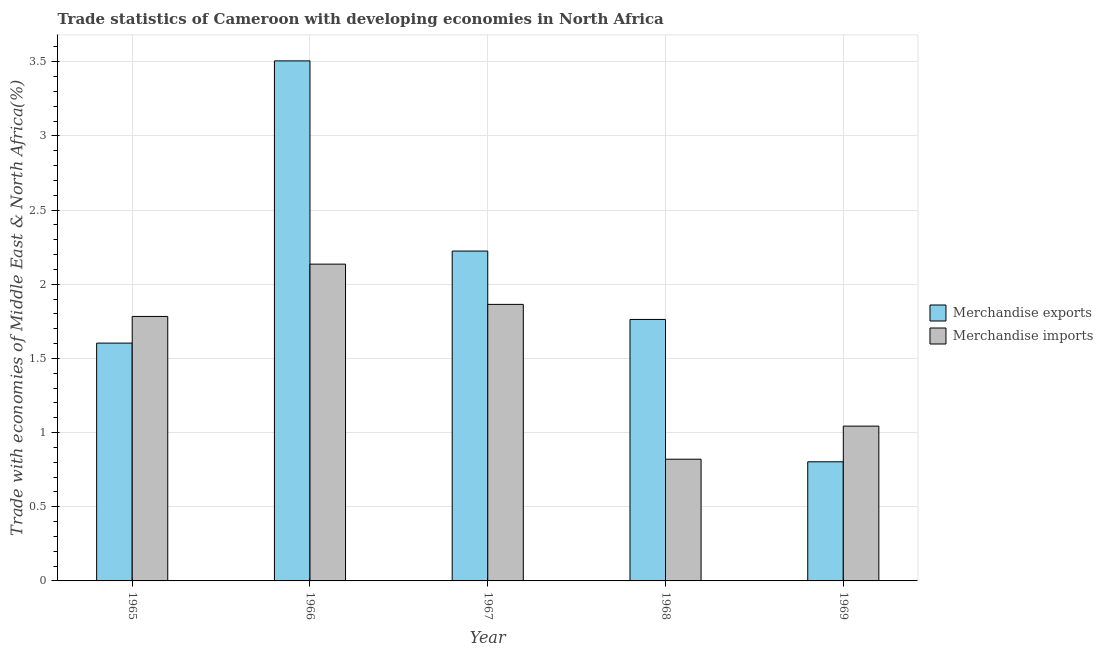Are the number of bars per tick equal to the number of legend labels?
Offer a terse response. Yes. How many bars are there on the 2nd tick from the left?
Offer a very short reply. 2. How many bars are there on the 4th tick from the right?
Your response must be concise. 2. What is the label of the 3rd group of bars from the left?
Ensure brevity in your answer.  1967. What is the merchandise exports in 1966?
Offer a terse response. 3.51. Across all years, what is the maximum merchandise imports?
Offer a terse response. 2.14. Across all years, what is the minimum merchandise imports?
Give a very brief answer. 0.82. In which year was the merchandise exports maximum?
Offer a very short reply. 1966. In which year was the merchandise imports minimum?
Ensure brevity in your answer.  1968. What is the total merchandise imports in the graph?
Offer a very short reply. 7.65. What is the difference between the merchandise imports in 1968 and that in 1969?
Offer a terse response. -0.22. What is the difference between the merchandise exports in 1968 and the merchandise imports in 1967?
Give a very brief answer. -0.46. What is the average merchandise exports per year?
Ensure brevity in your answer.  1.98. In how many years, is the merchandise exports greater than 2.4 %?
Your response must be concise. 1. What is the ratio of the merchandise imports in 1966 to that in 1968?
Your answer should be very brief. 2.6. Is the merchandise imports in 1968 less than that in 1969?
Offer a terse response. Yes. Is the difference between the merchandise imports in 1965 and 1968 greater than the difference between the merchandise exports in 1965 and 1968?
Your answer should be compact. No. What is the difference between the highest and the second highest merchandise exports?
Offer a very short reply. 1.28. What is the difference between the highest and the lowest merchandise exports?
Your response must be concise. 2.7. In how many years, is the merchandise exports greater than the average merchandise exports taken over all years?
Your response must be concise. 2. Is the sum of the merchandise exports in 1965 and 1966 greater than the maximum merchandise imports across all years?
Your answer should be very brief. Yes. What does the 2nd bar from the left in 1967 represents?
Provide a succinct answer. Merchandise imports. What does the 1st bar from the right in 1966 represents?
Ensure brevity in your answer.  Merchandise imports. Are all the bars in the graph horizontal?
Offer a terse response. No. How many years are there in the graph?
Keep it short and to the point. 5. Are the values on the major ticks of Y-axis written in scientific E-notation?
Provide a succinct answer. No. Where does the legend appear in the graph?
Offer a very short reply. Center right. How many legend labels are there?
Your answer should be compact. 2. How are the legend labels stacked?
Provide a short and direct response. Vertical. What is the title of the graph?
Offer a very short reply. Trade statistics of Cameroon with developing economies in North Africa. What is the label or title of the X-axis?
Your answer should be very brief. Year. What is the label or title of the Y-axis?
Provide a succinct answer. Trade with economies of Middle East & North Africa(%). What is the Trade with economies of Middle East & North Africa(%) in Merchandise exports in 1965?
Offer a very short reply. 1.6. What is the Trade with economies of Middle East & North Africa(%) in Merchandise imports in 1965?
Give a very brief answer. 1.78. What is the Trade with economies of Middle East & North Africa(%) in Merchandise exports in 1966?
Provide a succinct answer. 3.51. What is the Trade with economies of Middle East & North Africa(%) in Merchandise imports in 1966?
Your answer should be very brief. 2.14. What is the Trade with economies of Middle East & North Africa(%) in Merchandise exports in 1967?
Your answer should be compact. 2.22. What is the Trade with economies of Middle East & North Africa(%) in Merchandise imports in 1967?
Offer a terse response. 1.86. What is the Trade with economies of Middle East & North Africa(%) in Merchandise exports in 1968?
Offer a terse response. 1.76. What is the Trade with economies of Middle East & North Africa(%) in Merchandise imports in 1968?
Offer a very short reply. 0.82. What is the Trade with economies of Middle East & North Africa(%) in Merchandise exports in 1969?
Provide a short and direct response. 0.8. What is the Trade with economies of Middle East & North Africa(%) of Merchandise imports in 1969?
Keep it short and to the point. 1.04. Across all years, what is the maximum Trade with economies of Middle East & North Africa(%) of Merchandise exports?
Ensure brevity in your answer.  3.51. Across all years, what is the maximum Trade with economies of Middle East & North Africa(%) of Merchandise imports?
Offer a terse response. 2.14. Across all years, what is the minimum Trade with economies of Middle East & North Africa(%) of Merchandise exports?
Make the answer very short. 0.8. Across all years, what is the minimum Trade with economies of Middle East & North Africa(%) in Merchandise imports?
Provide a succinct answer. 0.82. What is the total Trade with economies of Middle East & North Africa(%) of Merchandise exports in the graph?
Keep it short and to the point. 9.9. What is the total Trade with economies of Middle East & North Africa(%) of Merchandise imports in the graph?
Provide a succinct answer. 7.65. What is the difference between the Trade with economies of Middle East & North Africa(%) in Merchandise exports in 1965 and that in 1966?
Make the answer very short. -1.9. What is the difference between the Trade with economies of Middle East & North Africa(%) of Merchandise imports in 1965 and that in 1966?
Ensure brevity in your answer.  -0.35. What is the difference between the Trade with economies of Middle East & North Africa(%) of Merchandise exports in 1965 and that in 1967?
Your response must be concise. -0.62. What is the difference between the Trade with economies of Middle East & North Africa(%) of Merchandise imports in 1965 and that in 1967?
Provide a succinct answer. -0.08. What is the difference between the Trade with economies of Middle East & North Africa(%) in Merchandise exports in 1965 and that in 1968?
Provide a succinct answer. -0.16. What is the difference between the Trade with economies of Middle East & North Africa(%) in Merchandise imports in 1965 and that in 1968?
Give a very brief answer. 0.96. What is the difference between the Trade with economies of Middle East & North Africa(%) of Merchandise exports in 1965 and that in 1969?
Offer a very short reply. 0.8. What is the difference between the Trade with economies of Middle East & North Africa(%) of Merchandise imports in 1965 and that in 1969?
Your response must be concise. 0.74. What is the difference between the Trade with economies of Middle East & North Africa(%) of Merchandise exports in 1966 and that in 1967?
Your answer should be very brief. 1.28. What is the difference between the Trade with economies of Middle East & North Africa(%) of Merchandise imports in 1966 and that in 1967?
Your answer should be compact. 0.27. What is the difference between the Trade with economies of Middle East & North Africa(%) of Merchandise exports in 1966 and that in 1968?
Offer a very short reply. 1.74. What is the difference between the Trade with economies of Middle East & North Africa(%) of Merchandise imports in 1966 and that in 1968?
Offer a terse response. 1.32. What is the difference between the Trade with economies of Middle East & North Africa(%) of Merchandise exports in 1966 and that in 1969?
Offer a terse response. 2.7. What is the difference between the Trade with economies of Middle East & North Africa(%) of Merchandise imports in 1966 and that in 1969?
Offer a terse response. 1.09. What is the difference between the Trade with economies of Middle East & North Africa(%) in Merchandise exports in 1967 and that in 1968?
Make the answer very short. 0.46. What is the difference between the Trade with economies of Middle East & North Africa(%) of Merchandise imports in 1967 and that in 1968?
Your answer should be very brief. 1.04. What is the difference between the Trade with economies of Middle East & North Africa(%) in Merchandise exports in 1967 and that in 1969?
Provide a succinct answer. 1.42. What is the difference between the Trade with economies of Middle East & North Africa(%) in Merchandise imports in 1967 and that in 1969?
Your response must be concise. 0.82. What is the difference between the Trade with economies of Middle East & North Africa(%) of Merchandise exports in 1968 and that in 1969?
Provide a short and direct response. 0.96. What is the difference between the Trade with economies of Middle East & North Africa(%) of Merchandise imports in 1968 and that in 1969?
Give a very brief answer. -0.22. What is the difference between the Trade with economies of Middle East & North Africa(%) of Merchandise exports in 1965 and the Trade with economies of Middle East & North Africa(%) of Merchandise imports in 1966?
Offer a terse response. -0.53. What is the difference between the Trade with economies of Middle East & North Africa(%) of Merchandise exports in 1965 and the Trade with economies of Middle East & North Africa(%) of Merchandise imports in 1967?
Offer a terse response. -0.26. What is the difference between the Trade with economies of Middle East & North Africa(%) of Merchandise exports in 1965 and the Trade with economies of Middle East & North Africa(%) of Merchandise imports in 1968?
Provide a short and direct response. 0.78. What is the difference between the Trade with economies of Middle East & North Africa(%) in Merchandise exports in 1965 and the Trade with economies of Middle East & North Africa(%) in Merchandise imports in 1969?
Provide a succinct answer. 0.56. What is the difference between the Trade with economies of Middle East & North Africa(%) in Merchandise exports in 1966 and the Trade with economies of Middle East & North Africa(%) in Merchandise imports in 1967?
Make the answer very short. 1.64. What is the difference between the Trade with economies of Middle East & North Africa(%) of Merchandise exports in 1966 and the Trade with economies of Middle East & North Africa(%) of Merchandise imports in 1968?
Make the answer very short. 2.69. What is the difference between the Trade with economies of Middle East & North Africa(%) of Merchandise exports in 1966 and the Trade with economies of Middle East & North Africa(%) of Merchandise imports in 1969?
Make the answer very short. 2.46. What is the difference between the Trade with economies of Middle East & North Africa(%) of Merchandise exports in 1967 and the Trade with economies of Middle East & North Africa(%) of Merchandise imports in 1968?
Offer a very short reply. 1.4. What is the difference between the Trade with economies of Middle East & North Africa(%) in Merchandise exports in 1967 and the Trade with economies of Middle East & North Africa(%) in Merchandise imports in 1969?
Your answer should be compact. 1.18. What is the difference between the Trade with economies of Middle East & North Africa(%) of Merchandise exports in 1968 and the Trade with economies of Middle East & North Africa(%) of Merchandise imports in 1969?
Ensure brevity in your answer.  0.72. What is the average Trade with economies of Middle East & North Africa(%) of Merchandise exports per year?
Give a very brief answer. 1.98. What is the average Trade with economies of Middle East & North Africa(%) of Merchandise imports per year?
Make the answer very short. 1.53. In the year 1965, what is the difference between the Trade with economies of Middle East & North Africa(%) in Merchandise exports and Trade with economies of Middle East & North Africa(%) in Merchandise imports?
Ensure brevity in your answer.  -0.18. In the year 1966, what is the difference between the Trade with economies of Middle East & North Africa(%) in Merchandise exports and Trade with economies of Middle East & North Africa(%) in Merchandise imports?
Your response must be concise. 1.37. In the year 1967, what is the difference between the Trade with economies of Middle East & North Africa(%) of Merchandise exports and Trade with economies of Middle East & North Africa(%) of Merchandise imports?
Your answer should be compact. 0.36. In the year 1968, what is the difference between the Trade with economies of Middle East & North Africa(%) in Merchandise exports and Trade with economies of Middle East & North Africa(%) in Merchandise imports?
Your response must be concise. 0.94. In the year 1969, what is the difference between the Trade with economies of Middle East & North Africa(%) of Merchandise exports and Trade with economies of Middle East & North Africa(%) of Merchandise imports?
Keep it short and to the point. -0.24. What is the ratio of the Trade with economies of Middle East & North Africa(%) of Merchandise exports in 1965 to that in 1966?
Ensure brevity in your answer.  0.46. What is the ratio of the Trade with economies of Middle East & North Africa(%) of Merchandise imports in 1965 to that in 1966?
Provide a succinct answer. 0.83. What is the ratio of the Trade with economies of Middle East & North Africa(%) in Merchandise exports in 1965 to that in 1967?
Keep it short and to the point. 0.72. What is the ratio of the Trade with economies of Middle East & North Africa(%) in Merchandise imports in 1965 to that in 1967?
Give a very brief answer. 0.96. What is the ratio of the Trade with economies of Middle East & North Africa(%) in Merchandise exports in 1965 to that in 1968?
Make the answer very short. 0.91. What is the ratio of the Trade with economies of Middle East & North Africa(%) in Merchandise imports in 1965 to that in 1968?
Provide a succinct answer. 2.17. What is the ratio of the Trade with economies of Middle East & North Africa(%) of Merchandise exports in 1965 to that in 1969?
Provide a short and direct response. 2. What is the ratio of the Trade with economies of Middle East & North Africa(%) of Merchandise imports in 1965 to that in 1969?
Ensure brevity in your answer.  1.71. What is the ratio of the Trade with economies of Middle East & North Africa(%) in Merchandise exports in 1966 to that in 1967?
Provide a succinct answer. 1.58. What is the ratio of the Trade with economies of Middle East & North Africa(%) in Merchandise imports in 1966 to that in 1967?
Offer a terse response. 1.15. What is the ratio of the Trade with economies of Middle East & North Africa(%) in Merchandise exports in 1966 to that in 1968?
Provide a succinct answer. 1.99. What is the ratio of the Trade with economies of Middle East & North Africa(%) of Merchandise imports in 1966 to that in 1968?
Your answer should be compact. 2.6. What is the ratio of the Trade with economies of Middle East & North Africa(%) in Merchandise exports in 1966 to that in 1969?
Make the answer very short. 4.37. What is the ratio of the Trade with economies of Middle East & North Africa(%) of Merchandise imports in 1966 to that in 1969?
Offer a very short reply. 2.05. What is the ratio of the Trade with economies of Middle East & North Africa(%) of Merchandise exports in 1967 to that in 1968?
Provide a short and direct response. 1.26. What is the ratio of the Trade with economies of Middle East & North Africa(%) in Merchandise imports in 1967 to that in 1968?
Provide a short and direct response. 2.27. What is the ratio of the Trade with economies of Middle East & North Africa(%) of Merchandise exports in 1967 to that in 1969?
Your response must be concise. 2.77. What is the ratio of the Trade with economies of Middle East & North Africa(%) in Merchandise imports in 1967 to that in 1969?
Provide a succinct answer. 1.79. What is the ratio of the Trade with economies of Middle East & North Africa(%) in Merchandise exports in 1968 to that in 1969?
Keep it short and to the point. 2.19. What is the ratio of the Trade with economies of Middle East & North Africa(%) of Merchandise imports in 1968 to that in 1969?
Make the answer very short. 0.79. What is the difference between the highest and the second highest Trade with economies of Middle East & North Africa(%) of Merchandise exports?
Offer a very short reply. 1.28. What is the difference between the highest and the second highest Trade with economies of Middle East & North Africa(%) of Merchandise imports?
Offer a very short reply. 0.27. What is the difference between the highest and the lowest Trade with economies of Middle East & North Africa(%) in Merchandise exports?
Your answer should be very brief. 2.7. What is the difference between the highest and the lowest Trade with economies of Middle East & North Africa(%) in Merchandise imports?
Ensure brevity in your answer.  1.32. 